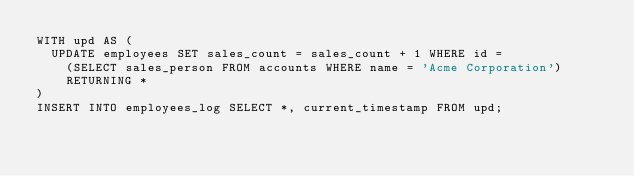Convert code to text. <code><loc_0><loc_0><loc_500><loc_500><_SQL_>WITH upd AS (
  UPDATE employees SET sales_count = sales_count + 1 WHERE id =
    (SELECT sales_person FROM accounts WHERE name = 'Acme Corporation')
    RETURNING *
)
INSERT INTO employees_log SELECT *, current_timestamp FROM upd;
</code> 